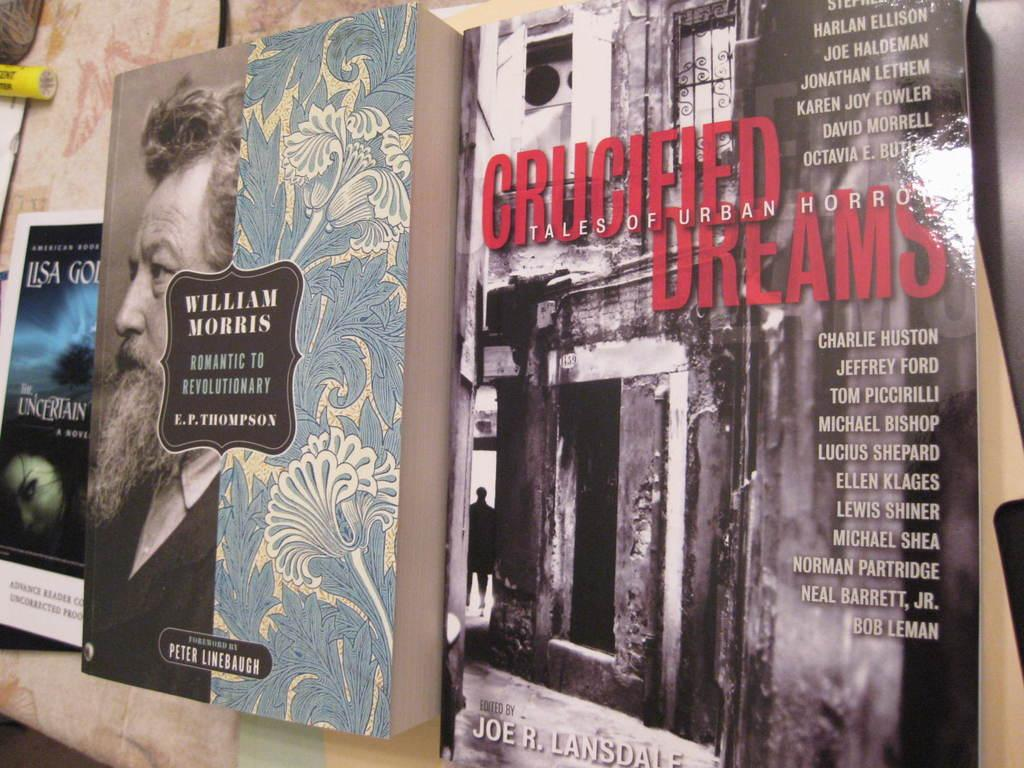<image>
Share a concise interpretation of the image provided. Several books on display including crucified dreams tales of urban horror. 